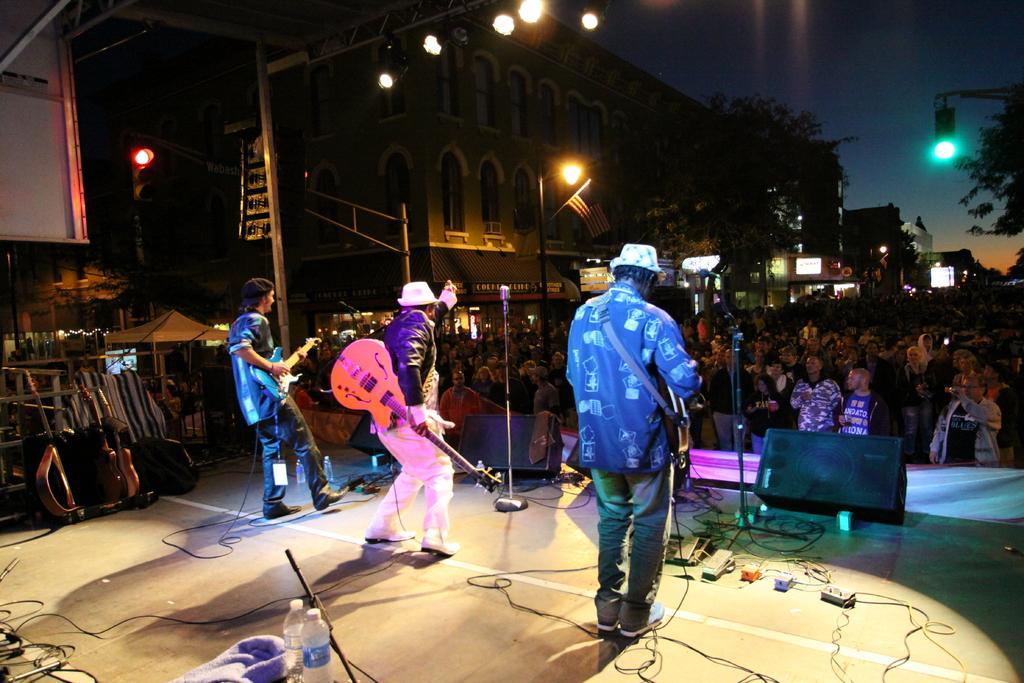Please provide a concise description of this image. There are three members standing on the stage. Three of them are holding a guitars in their hands. Everyone is having a microphone in front of them. In the down there are some people standing and enjoying the music concert. In the background there is a tree, 
building, street lights and sky here. 